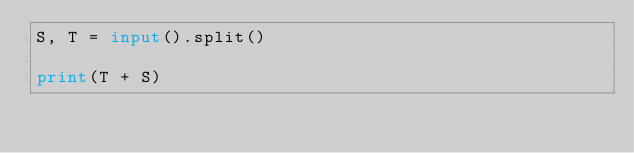<code> <loc_0><loc_0><loc_500><loc_500><_Python_>S, T = input().split()

print(T + S)
</code> 